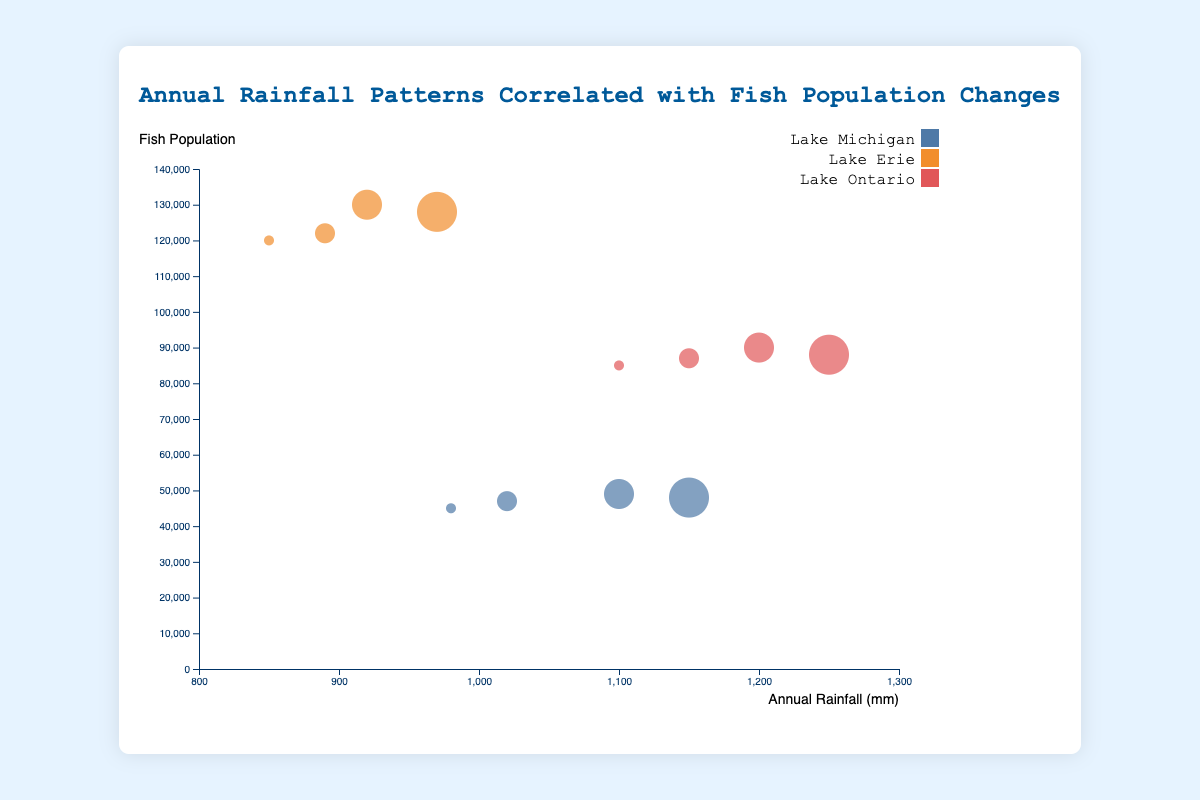How many data points represent Lake Michigan between the years 2015 to 2018? There are four years of data (2015, 2016, 2017, 2018) for Lake Michigan in the data set provided. Each year has one data point associated with it.
Answer: 4 What is the color representing Lake Erie in the chart? The color representing Lake Erie on the chart is indicated in the legend on the right. Lake Erie is represented by the color orange.
Answer: Orange Which lake had the highest fish population in any given year according to the data shown? By observing the y-axis (fish population) and looking at the highest point achieved, Lake Erie had the highest fish population in 2017 with 130,000 fish.
Answer: Lake Erie What is the trend of annual rainfall and fish population for Rainbow Trout in Lake Michigan from 2015 to 2018? The data points for Rainbow Trout in Lake Michigan show that as annual rainfall increased from 980 mm to 1150 mm from 2015 to 2018, the fish population increased to 49,000 in 2017 but then slightly decreased to 48,000 in 2018.
Answer: Fish population increased and then slightly decreased What is the difference in annual rainfall between Lake Ontario and Lake Erie in 2018? In 2018, Lake Ontario had an annual rainfall of 1250 mm and Lake Erie had 970 mm. The difference is 1250 - 970 = 280 mm.
Answer: 280 mm Is there a year when all three lakes experienced an increase in rainfall compared to the previous year? By checking the annual rainfall data for each lake, we find that for 2016, all lakes (Michigan, Erie, and Ontario) had an increase in rainfall compared to 2015.
Answer: Yes, in 2016 Which fish species had the largest population in 2015? By comparing the fish populations for each species in 2015, Walleye in Lake Erie had the largest population with 120,000 fish.
Answer: Walleye How do the sizes of the bubbles vary in the chart? The sizes of the bubbles vary based on the year. The size increases from the smallest in 2015 to the largest in 2018. Bubbles for 2015 are smallest, followed by 2016, 2017, and 2018 being the largest.
Answer: Size increases with year What is the relationship between annual rainfall and fish population for Smallmouth Bass in Lake Ontario from 2015 to 2018? From the data, as annual rainfall increased for Lake Ontario from 1100 mm in 2015 to 1250 mm in 2018, the fish population initially increased from 85,000 in 2015 to 90,000 in 2017, then slightly decreased to 88,000 in 2018.
Answer: Fish population increased then slightly decreased Did any lake show a constant fish population despite changes in rainfall over the years? By examining the data, none of the lakes showed a constant fish population from year to year while experiencing changes in rainfall. All lakes had some variations in their fish populations over the years.
Answer: No 